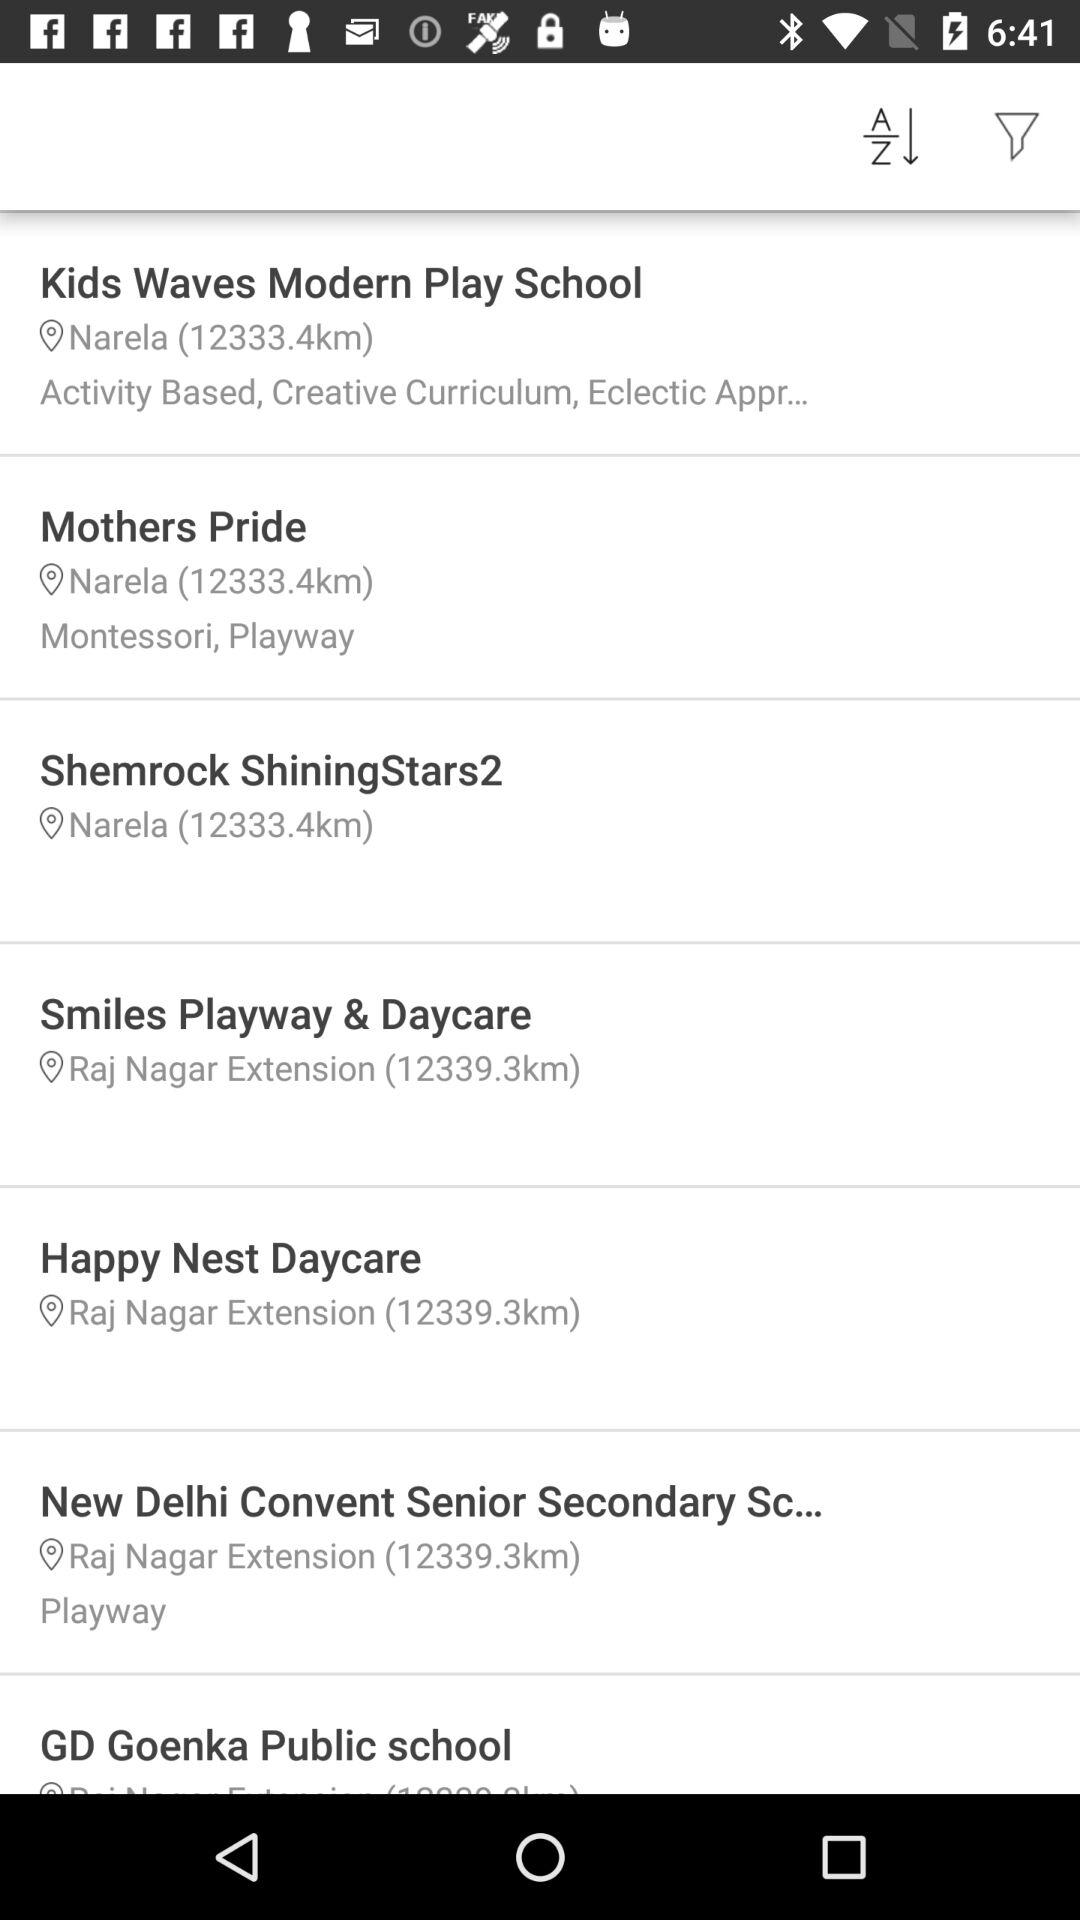What is the current location of "Shemrock ShiningStars2"? The current location is "Narela". 